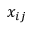<formula> <loc_0><loc_0><loc_500><loc_500>x _ { i j }</formula> 